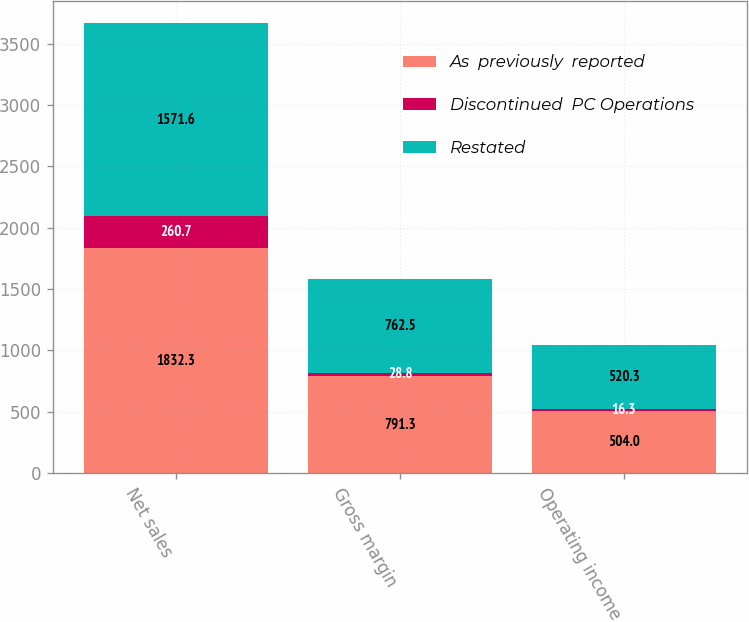Convert chart to OTSL. <chart><loc_0><loc_0><loc_500><loc_500><stacked_bar_chart><ecel><fcel>Net sales<fcel>Gross margin<fcel>Operating income<nl><fcel>As  previously  reported<fcel>1832.3<fcel>791.3<fcel>504<nl><fcel>Discontinued  PC Operations<fcel>260.7<fcel>28.8<fcel>16.3<nl><fcel>Restated<fcel>1571.6<fcel>762.5<fcel>520.3<nl></chart> 